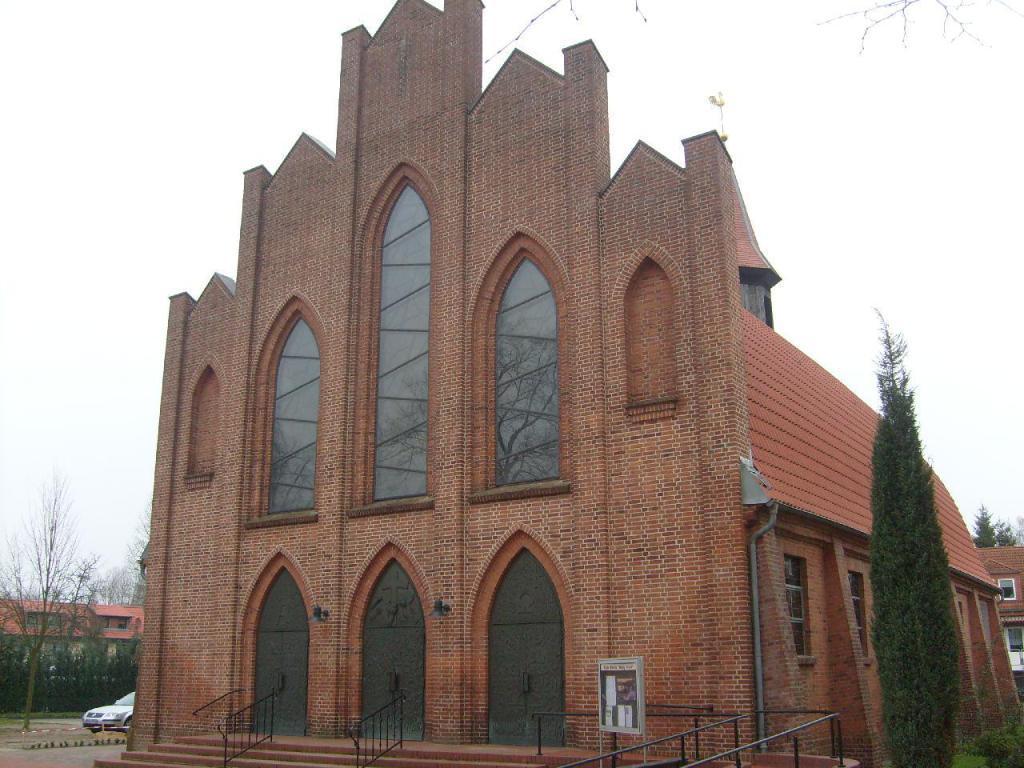In one or two sentences, can you explain what this image depicts? This image is taken in outdoors. In the middle of the image there is a building with windows, doors and wall with bricks. In the right side of the image there is a tree. In the left side of the image there is a tree and a house. There is a vehicle on the road. At the top of the image there is a sky. 